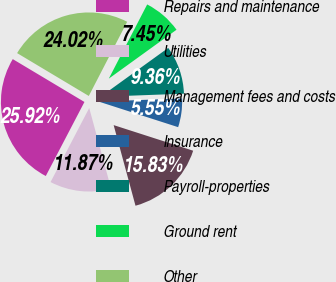Convert chart. <chart><loc_0><loc_0><loc_500><loc_500><pie_chart><fcel>Repairs and maintenance<fcel>Utilities<fcel>Management fees and costs<fcel>Insurance<fcel>Payroll-properties<fcel>Ground rent<fcel>Other<nl><fcel>25.92%<fcel>11.87%<fcel>15.83%<fcel>5.55%<fcel>9.36%<fcel>7.45%<fcel>24.02%<nl></chart> 